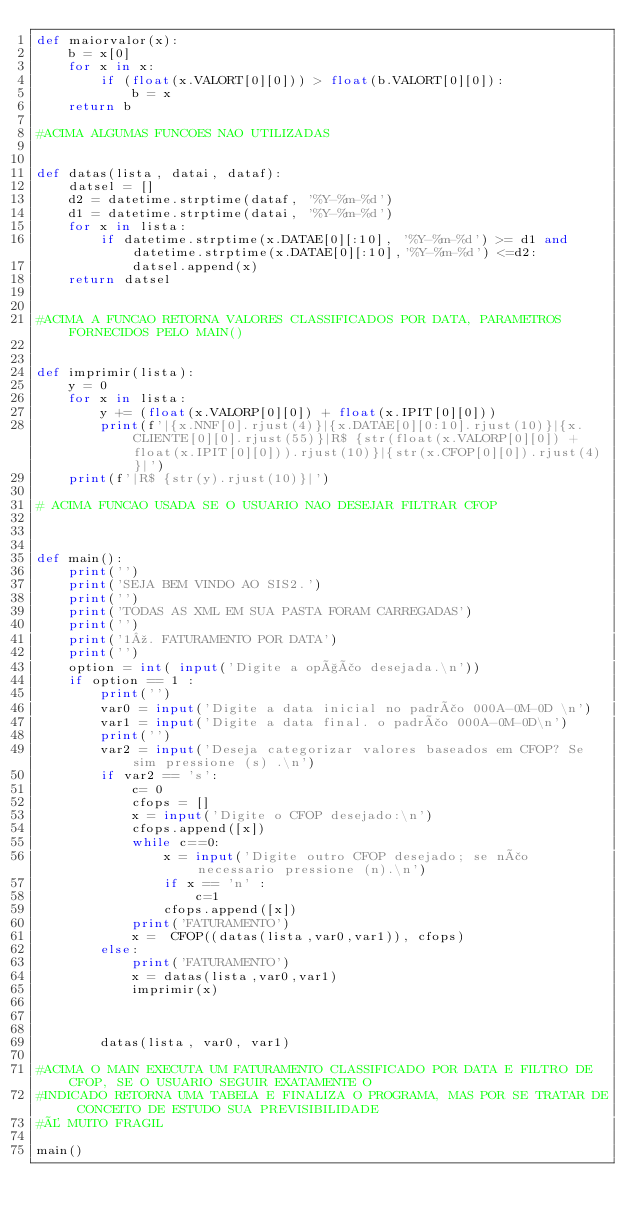<code> <loc_0><loc_0><loc_500><loc_500><_Python_>def maiorvalor(x):
    b = x[0]
    for x in x:
        if (float(x.VALORT[0][0])) > float(b.VALORT[0][0]):
            b = x
    return b     

#ACIMA ALGUMAS FUNCOES NAO UTILIZADAS       


def datas(lista, datai, dataf):
    datsel = []
    d2 = datetime.strptime(dataf, '%Y-%m-%d')
    d1 = datetime.strptime(datai, '%Y-%m-%d')
    for x in lista:
        if datetime.strptime(x.DATAE[0][:10], '%Y-%m-%d') >= d1 and datetime.strptime(x.DATAE[0][:10],'%Y-%m-%d') <=d2:
            datsel.append(x)
    return datsel        
           

#ACIMA A FUNCAO RETORNA VALORES CLASSIFICADOS POR DATA, PARAMETROS FORNECIDOS PELO MAIN()

            
def imprimir(lista):
    y = 0
    for x in lista: 
        y += (float(x.VALORP[0][0]) + float(x.IPIT[0][0]))
        print(f'|{x.NNF[0].rjust(4)}|{x.DATAE[0][0:10].rjust(10)}|{x.CLIENTE[0][0].rjust(55)}|R$ {str(float(x.VALORP[0][0]) + float(x.IPIT[0][0])).rjust(10)}|{str(x.CFOP[0][0]).rjust(4)}|')
    print(f'|R$ {str(y).rjust(10)}|')
        
# ACIMA FUNCAO USADA SE O USUARIO NAO DESEJAR FILTRAR CFOP



def main():
    print('')
    print('SEJA BEM VINDO AO SIS2.')
    print('')
    print('TODAS AS XML EM SUA PASTA FORAM CARREGADAS')
    print('')
    print('1º. FATURAMENTO POR DATA')
    print('')
    option = int( input('Digite a opção desejada.\n'))
    if option == 1 :
        print('')
        var0 = input('Digite a data inicial no padrão 000A-0M-0D \n')
        var1 = input('Digite a data final. o padrão 000A-0M-0D\n')
        print('')
        var2 = input('Deseja categorizar valores baseados em CFOP? Se sim pressione (s) .\n')
        if var2 == 's':
            c= 0
            cfops = []
            x = input('Digite o CFOP desejado:\n')
            cfops.append([x])
            while c==0:
                x = input('Digite outro CFOP desejado; se não necessario pressione (n).\n')
                if x == 'n' :
                    c=1 
                cfops.append([x])
            print('FATURAMENTO')
            x =  CFOP((datas(lista,var0,var1)), cfops)
        else:
            print('FATURAMENTO')
            x = datas(lista,var0,var1)
            imprimir(x)
            

       
        datas(lista, var0, var1)

#ACIMA O MAIN EXECUTA UM FATURAMENTO CLASSIFICADO POR DATA E FILTRO DE CFOP, SE O USUARIO SEGUIR EXATAMENTE O 
#INDICADO RETORNA UMA TABELA E FINALIZA O PROGRAMA, MAS POR SE TRATAR DE CONCEITO DE ESTUDO SUA PREVISIBILIDADE 
#É MUITO FRAGIL

main()
   



</code> 